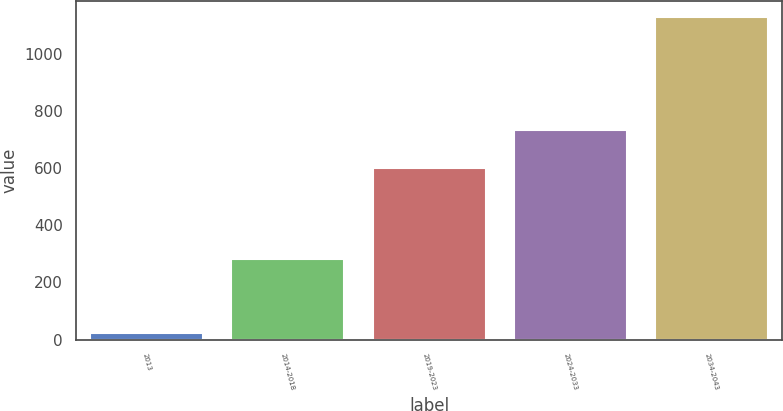<chart> <loc_0><loc_0><loc_500><loc_500><bar_chart><fcel>2013<fcel>2014-2018<fcel>2019-2023<fcel>2024-2033<fcel>2034-2043<nl><fcel>23<fcel>281<fcel>601<fcel>732<fcel>1128<nl></chart> 